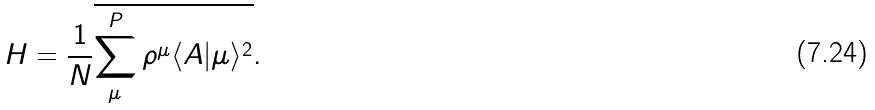Convert formula to latex. <formula><loc_0><loc_0><loc_500><loc_500>H = \frac { 1 } { N } \overline { \sum _ { \mu } ^ { P } \rho ^ { \mu } \langle A | \mu \rangle ^ { 2 } } .</formula> 